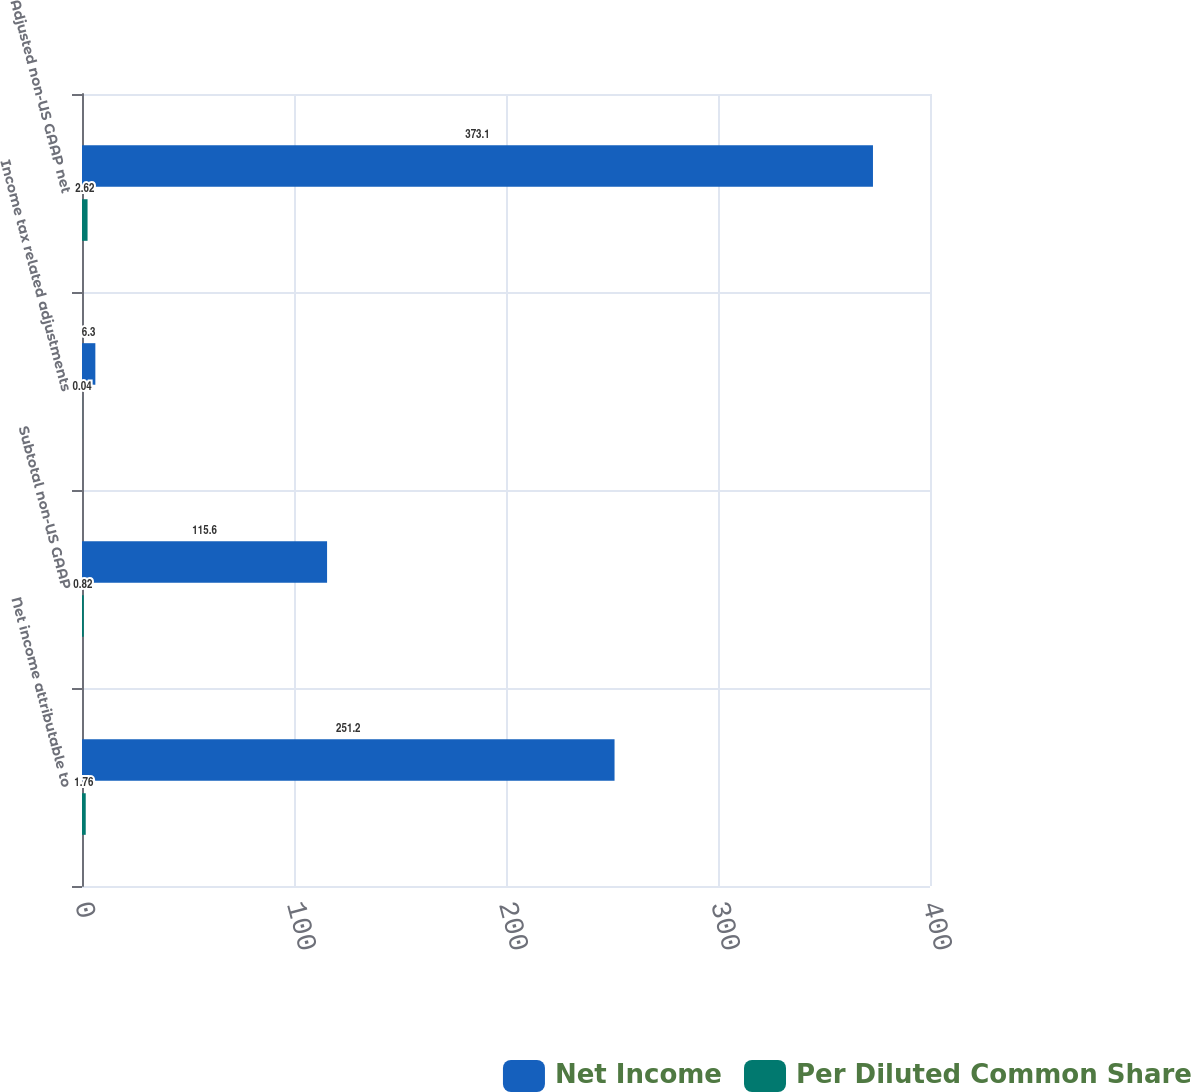<chart> <loc_0><loc_0><loc_500><loc_500><stacked_bar_chart><ecel><fcel>Net income attributable to<fcel>Subtotal non-US GAAP<fcel>Income tax related adjustments<fcel>Adjusted non-US GAAP net<nl><fcel>Net Income<fcel>251.2<fcel>115.6<fcel>6.3<fcel>373.1<nl><fcel>Per Diluted Common Share<fcel>1.76<fcel>0.82<fcel>0.04<fcel>2.62<nl></chart> 